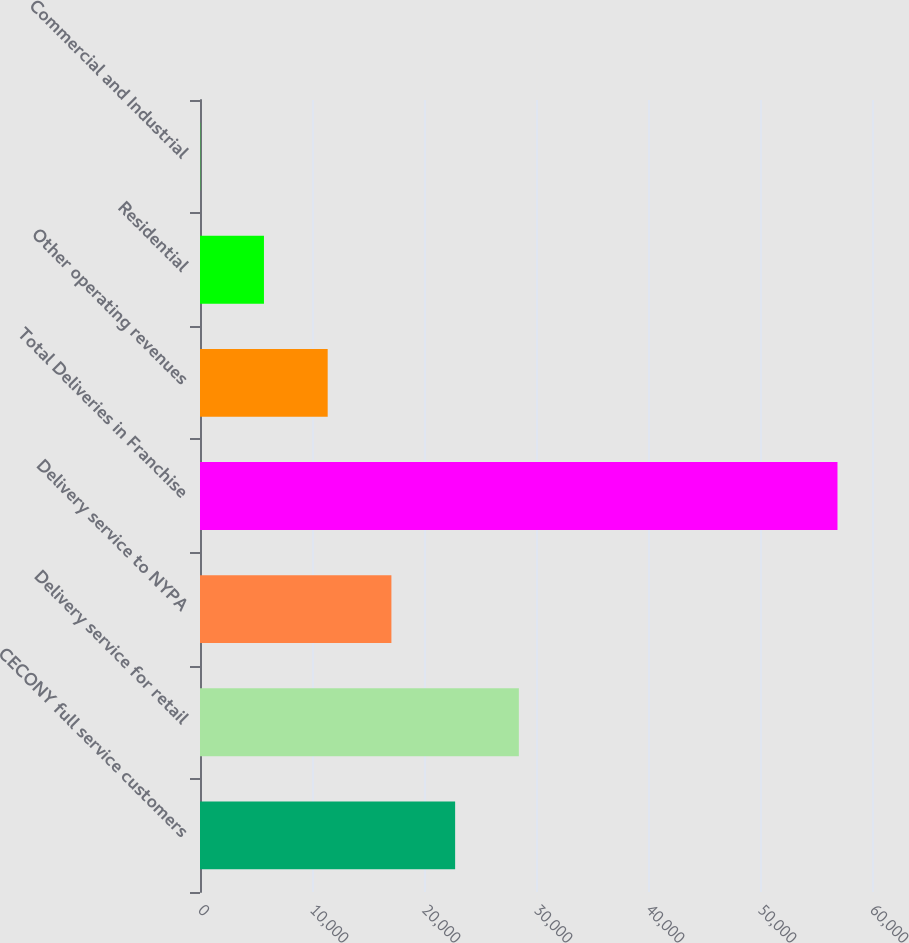Convert chart. <chart><loc_0><loc_0><loc_500><loc_500><bar_chart><fcel>CECONY full service customers<fcel>Delivery service for retail<fcel>Delivery service to NYPA<fcel>Total Deliveries in Franchise<fcel>Other operating revenues<fcel>Residential<fcel>Commercial and Industrial<nl><fcel>22779.6<fcel>28469.3<fcel>17089.8<fcel>56918<fcel>11400.1<fcel>5710.34<fcel>20.6<nl></chart> 